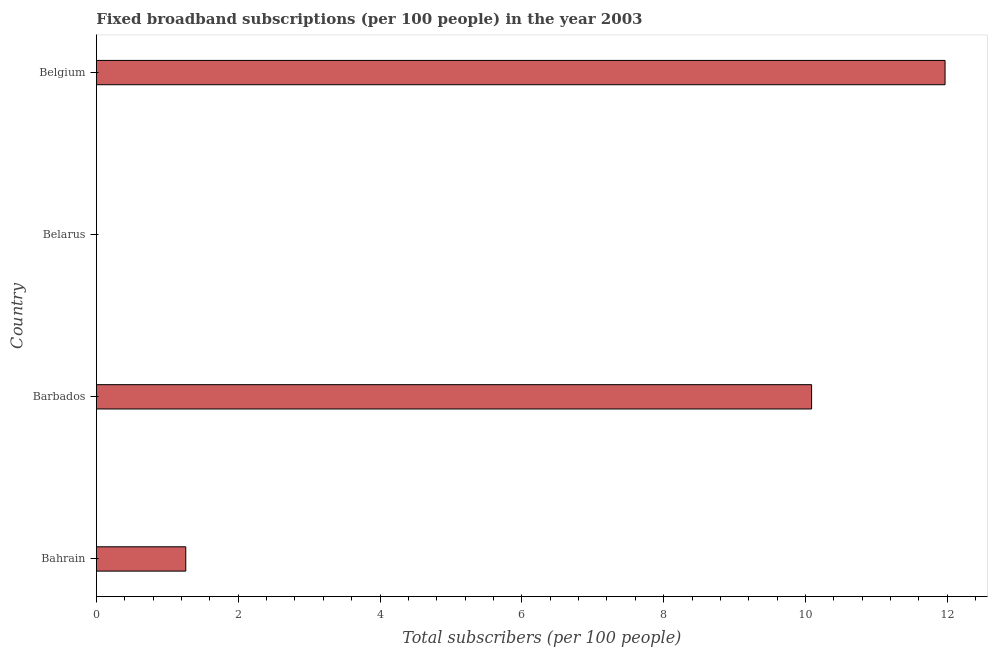Does the graph contain any zero values?
Your answer should be very brief. No. What is the title of the graph?
Your answer should be compact. Fixed broadband subscriptions (per 100 people) in the year 2003. What is the label or title of the X-axis?
Keep it short and to the point. Total subscribers (per 100 people). What is the label or title of the Y-axis?
Ensure brevity in your answer.  Country. What is the total number of fixed broadband subscriptions in Belarus?
Provide a short and direct response. 0. Across all countries, what is the maximum total number of fixed broadband subscriptions?
Your answer should be very brief. 11.97. Across all countries, what is the minimum total number of fixed broadband subscriptions?
Keep it short and to the point. 0. In which country was the total number of fixed broadband subscriptions maximum?
Your answer should be compact. Belgium. In which country was the total number of fixed broadband subscriptions minimum?
Make the answer very short. Belarus. What is the sum of the total number of fixed broadband subscriptions?
Provide a succinct answer. 23.32. What is the difference between the total number of fixed broadband subscriptions in Bahrain and Barbados?
Offer a very short reply. -8.82. What is the average total number of fixed broadband subscriptions per country?
Offer a terse response. 5.83. What is the median total number of fixed broadband subscriptions?
Make the answer very short. 5.67. What is the ratio of the total number of fixed broadband subscriptions in Bahrain to that in Belarus?
Provide a succinct answer. 1003.21. What is the difference between the highest and the second highest total number of fixed broadband subscriptions?
Your answer should be compact. 1.88. Is the sum of the total number of fixed broadband subscriptions in Barbados and Belarus greater than the maximum total number of fixed broadband subscriptions across all countries?
Your answer should be compact. No. What is the difference between the highest and the lowest total number of fixed broadband subscriptions?
Keep it short and to the point. 11.97. In how many countries, is the total number of fixed broadband subscriptions greater than the average total number of fixed broadband subscriptions taken over all countries?
Offer a very short reply. 2. Are all the bars in the graph horizontal?
Ensure brevity in your answer.  Yes. How many countries are there in the graph?
Offer a very short reply. 4. Are the values on the major ticks of X-axis written in scientific E-notation?
Offer a very short reply. No. What is the Total subscribers (per 100 people) of Bahrain?
Your answer should be very brief. 1.26. What is the Total subscribers (per 100 people) in Barbados?
Keep it short and to the point. 10.09. What is the Total subscribers (per 100 people) of Belarus?
Provide a short and direct response. 0. What is the Total subscribers (per 100 people) of Belgium?
Your answer should be very brief. 11.97. What is the difference between the Total subscribers (per 100 people) in Bahrain and Barbados?
Your answer should be compact. -8.83. What is the difference between the Total subscribers (per 100 people) in Bahrain and Belarus?
Your answer should be very brief. 1.26. What is the difference between the Total subscribers (per 100 people) in Bahrain and Belgium?
Give a very brief answer. -10.71. What is the difference between the Total subscribers (per 100 people) in Barbados and Belarus?
Make the answer very short. 10.09. What is the difference between the Total subscribers (per 100 people) in Barbados and Belgium?
Offer a very short reply. -1.88. What is the difference between the Total subscribers (per 100 people) in Belarus and Belgium?
Make the answer very short. -11.97. What is the ratio of the Total subscribers (per 100 people) in Bahrain to that in Barbados?
Give a very brief answer. 0.12. What is the ratio of the Total subscribers (per 100 people) in Bahrain to that in Belarus?
Provide a succinct answer. 1003.21. What is the ratio of the Total subscribers (per 100 people) in Bahrain to that in Belgium?
Ensure brevity in your answer.  0.1. What is the ratio of the Total subscribers (per 100 people) in Barbados to that in Belarus?
Your answer should be compact. 8023.46. What is the ratio of the Total subscribers (per 100 people) in Barbados to that in Belgium?
Give a very brief answer. 0.84. 